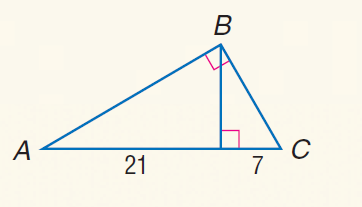Answer the mathemtical geometry problem and directly provide the correct option letter.
Question: Find the measure of the altitude drawn to the hypotenuse.
Choices: A: \sqrt { 7 } B: 3 C: 7 D: 7 \sqrt { 3 } D 